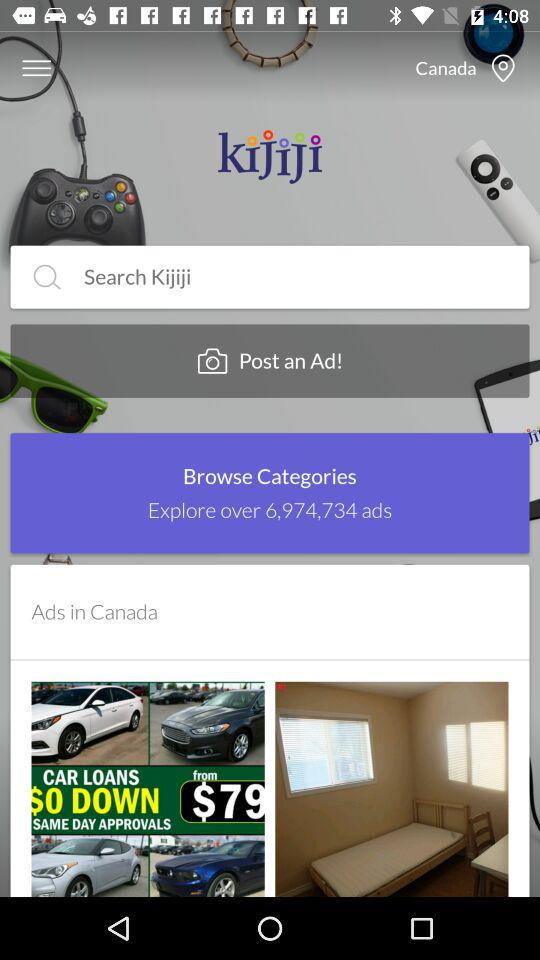What categories are available to be browsed?
When the provided information is insufficient, respond with <no answer>. <no answer> 